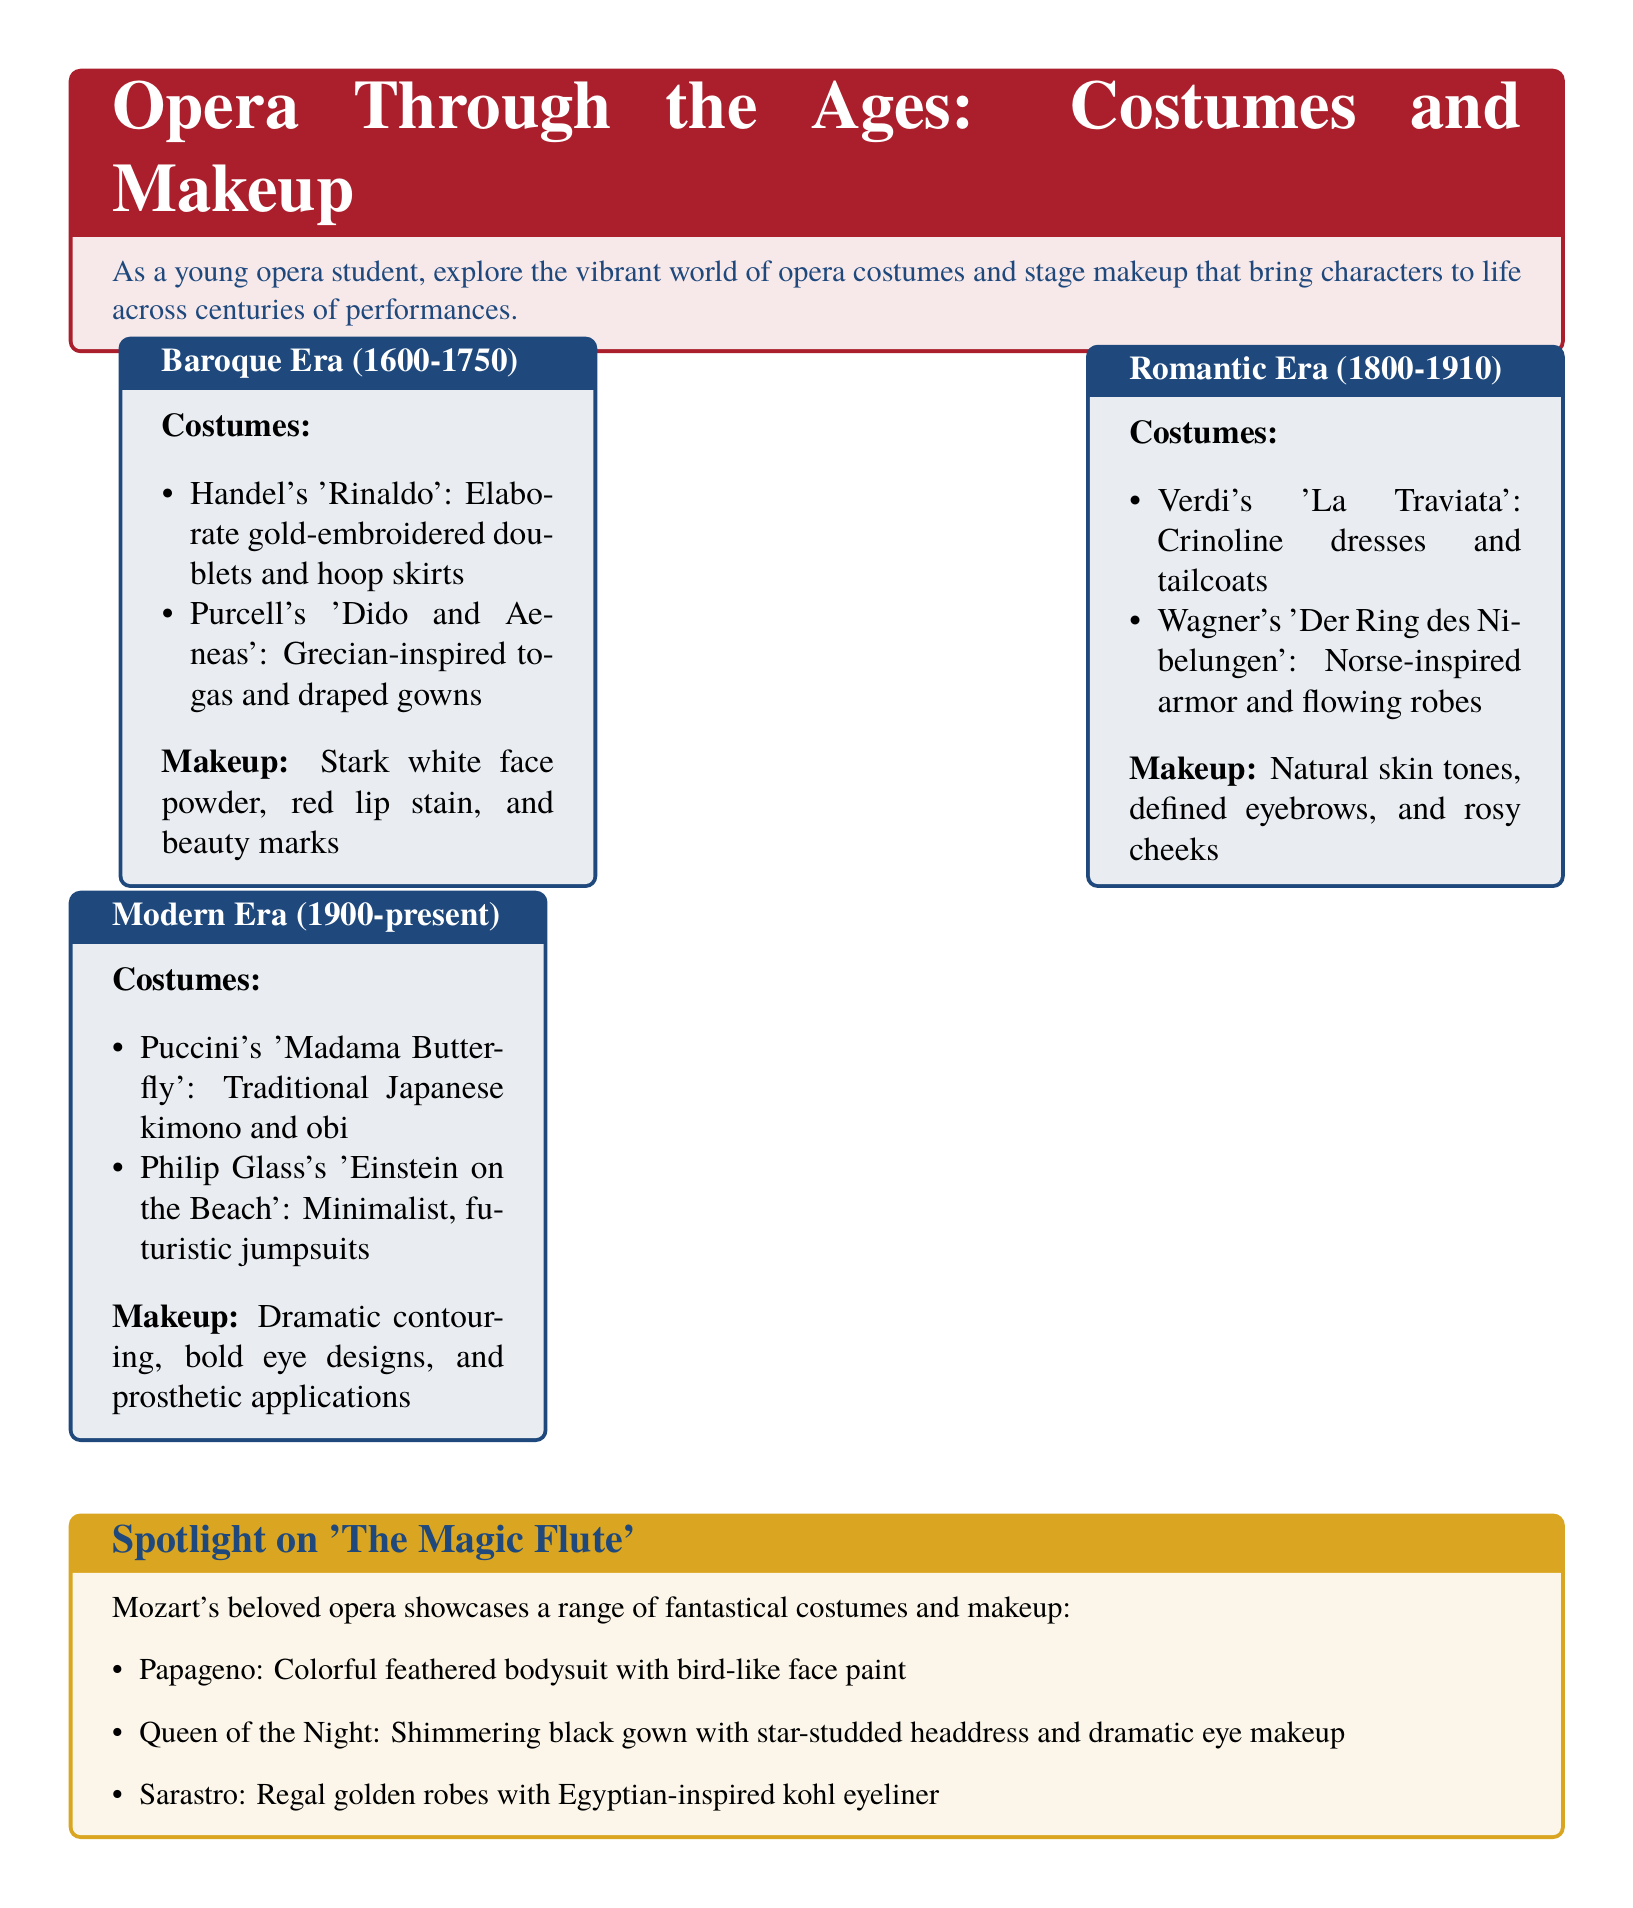What are the costumes in the Baroque Era? The costumes are listed in the Baroque Era section of the document, highlighting specific operas and styles such as gold-embroidered doublets and hoop skirts.
Answer: Elaborate gold-embroidered doublets and hoop skirts What is the primary makeup style for the Romantic Era? The primary makeup style is detailed in the Romantic Era section, emphasizing natural skin tones and defined features.
Answer: Natural skin tones, defined eyebrows, and rosy cheeks Which character in 'The Magic Flute' has a feathered bodysuit? The character who wears a feathered bodysuit is mentioned in the Spotlight section focused on 'The Magic Flute'.
Answer: Papageno What era features traditional Japanese costumes? The section on Modern Era details the specific costumes characterized as traditional Japanese, especially linked to a specific opera.
Answer: Modern Era What type of makeup is used in the Modern Era? The Modern Era section outlines the makeup style, particularly highlighting its dramatic and bold features.
Answer: Dramatic contouring, bold eye designs, and prosthetic applications Which opera features glamorous black gowns? The noted opera that showcases fabulous black gowns is detailed within the 'Spotlight on The Magic Flute' section, specifically connected to a key character.
Answer: The Magic Flute How are the costumes and makeup for ‘Der Ring des Nibelungen’? The details of costumes and makeup are summarized in the Romantic Era section, showcasing the specific styles attributed to this production.
Answer: Norse-inspired armor and flowing robes; natural skin tones, defined eyebrows, and rosy cheeks What color is associated with Opera Red? The document specifies the RGB color representation for Opera Red, relating to its visual design elements.
Answer: RGB(171,31,45) 